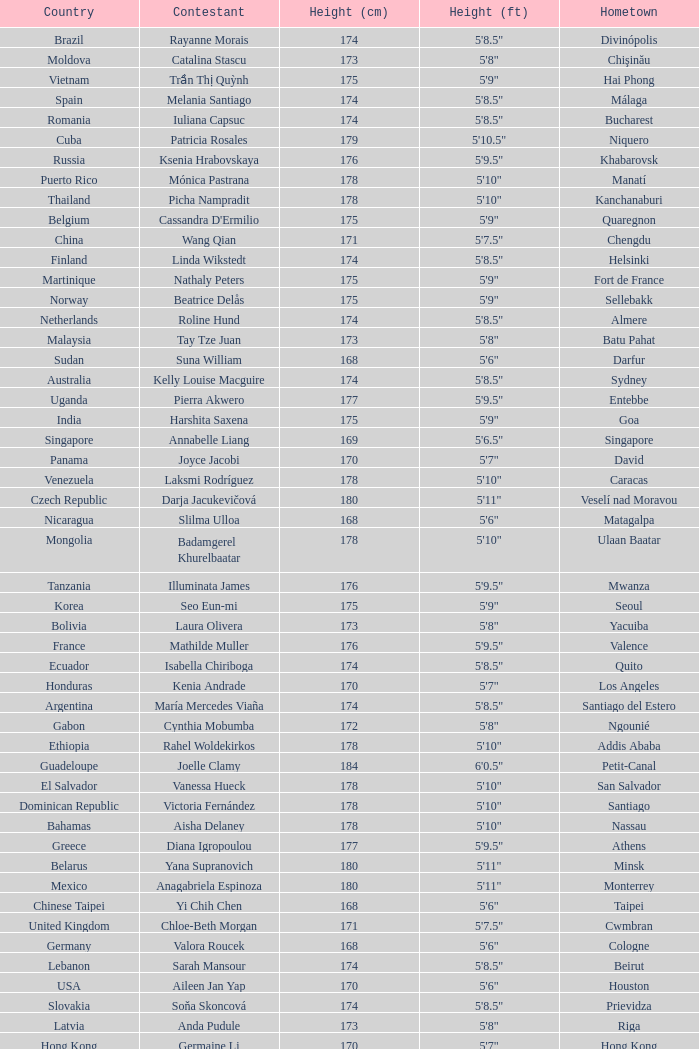What is Cynthia Mobumba's height? 5'8". 